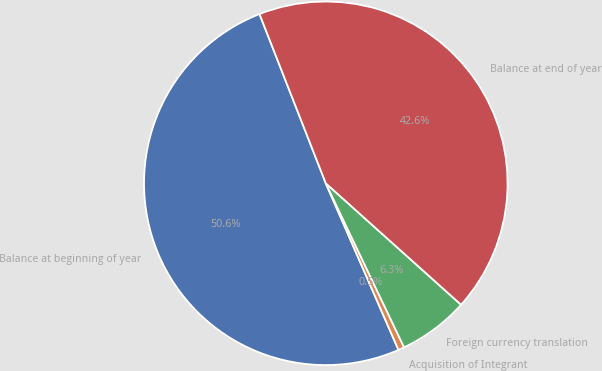Convert chart. <chart><loc_0><loc_0><loc_500><loc_500><pie_chart><fcel>Balance at beginning of year<fcel>Acquisition of Integrant<fcel>Foreign currency translation<fcel>Balance at end of year<nl><fcel>50.6%<fcel>0.54%<fcel>6.27%<fcel>42.58%<nl></chart> 